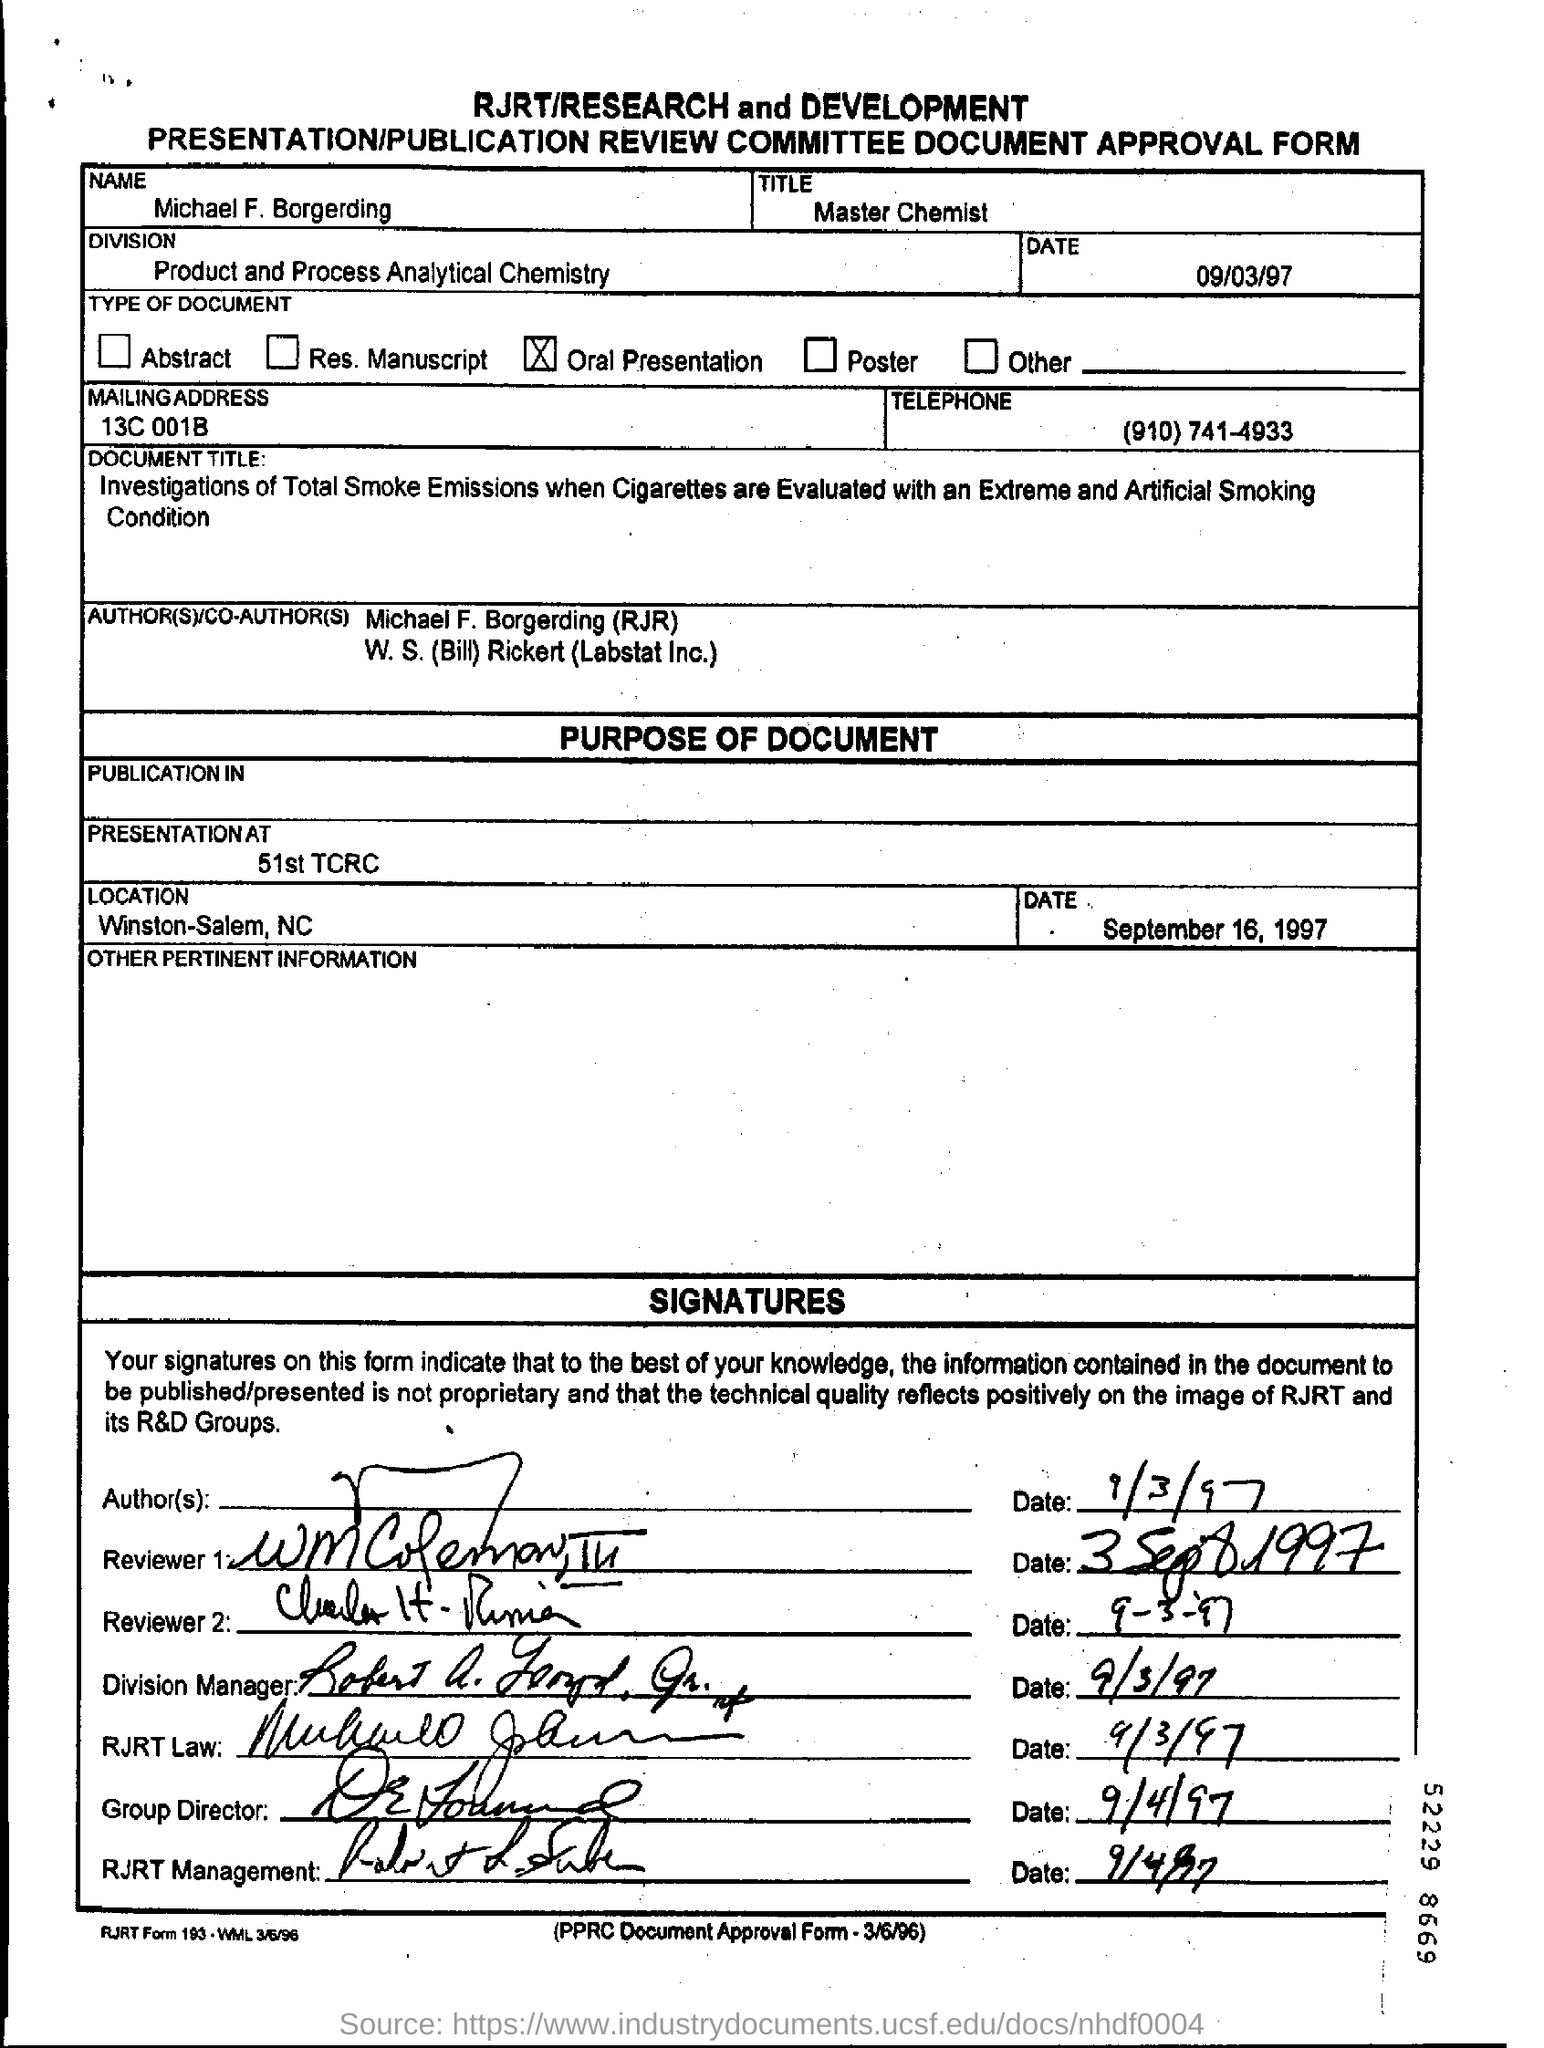Draw attention to some important aspects in this diagram. On September 3, 1997, reviewer 2 signed. Michael F. Borgerding holds the designation of Master Chemist. The Division Manager signed this document on September 3, 1997, as evidenced by the date written on the document. I, the Group Director, signed this document on September 4, 1997. The oral presentation type is conducted. 